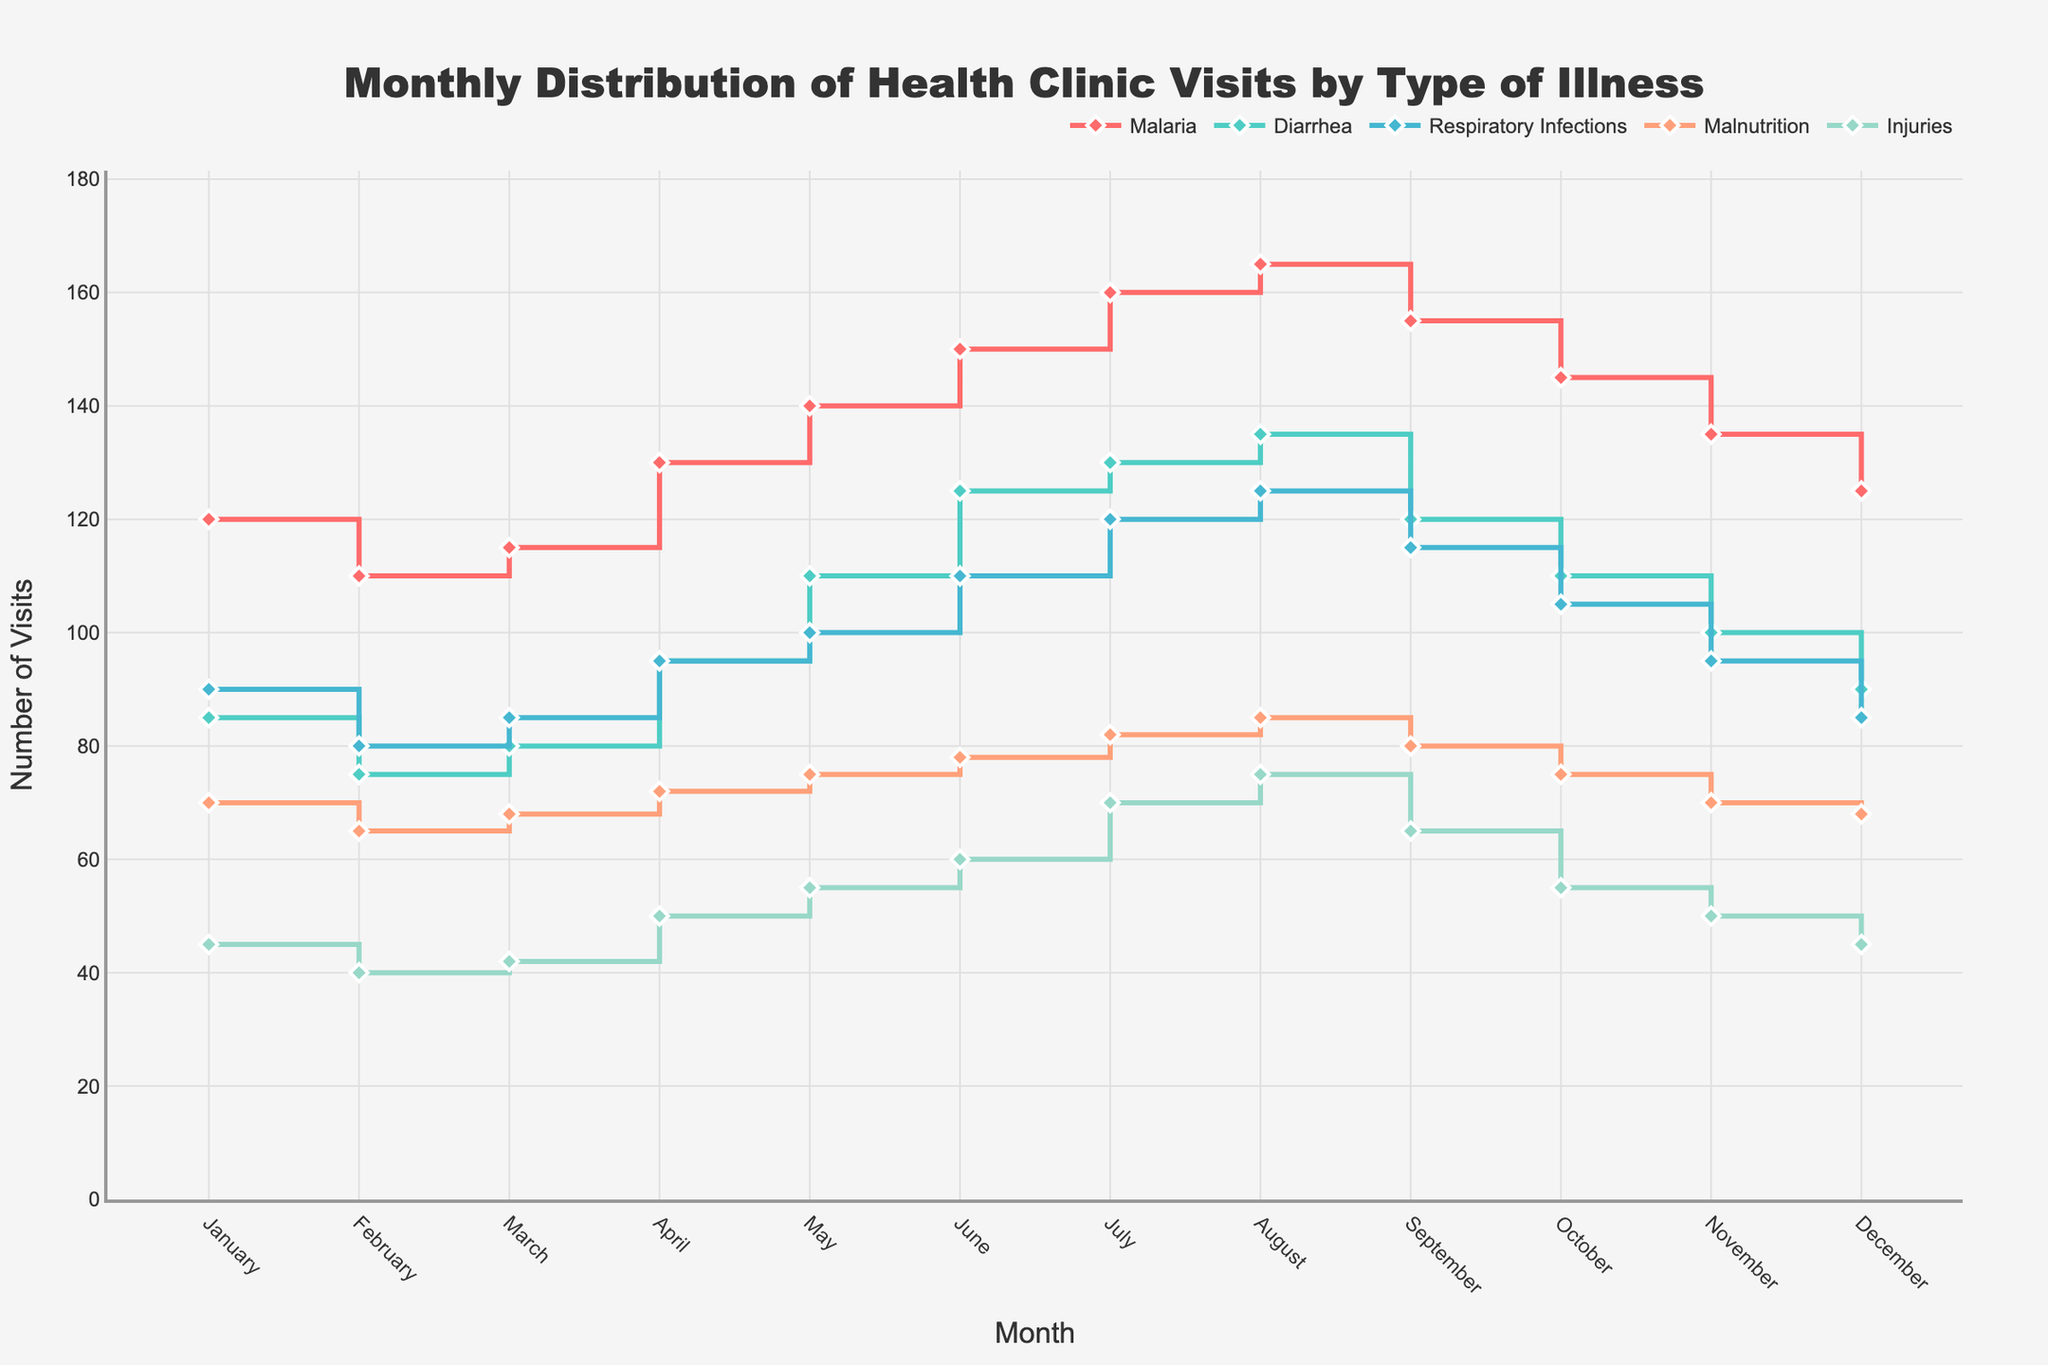What is the title of the plot? The title of the plot is usually the main heading at the top, which helps describe the data being shown. The title here specifically mentions the subject being depicted.
Answer: Monthly Distribution of Health Clinic Visits by Type of Illness What type of illness had the highest number of visits in July? To answer this, look for all the illnesses plotted for July and identify the one with the highest value.
Answer: Malaria How many health clinic visits were recorded for Malnutrition in April? Find the plot line for Malnutrition and look at the value where April is located.
Answer: 72 Which month had the highest number of visits for Injuries? Look at the values for Injuries across all months and identify the month with the highest value.
Answer: August What is the difference between the highest and lowest number of visits for Malaria? First, find the highest and lowest values for Malaria recorded in any month. Then, subtract the lowest value from the highest value. Highest (August: 165), Lowest (February: 110), Difference: 165 - 110.
Answer: 55 What is the average number of clinic visits for Diarrhea in the first quarter of the year (Jan-Mar)? Add up the number of visits for Diarrhea in January, February, and March and divide by the number of months (3). (85 + 75 + 80) / 3 = 80
Answer: 80 How does the number of visits for Respiratory Infections in December compare to November? Compare the values for Respiratory Infections in December and November. December: 85, November: 95.
Answer: December is 10 less than November Which illness shows the most consistent number of visits throughout the year? Look at the plot lines for all illnesses and observe which one has the least fluctuation or variation in values across months.
Answer: Malnutrition Identify the month where Malaria visits start a continuous increase until peaking. Observe the trend of Malaria across months and identify the month where a continuous upward trend begins until it reaches its highest value. The increase starts in April and peaks in August.
Answer: April What is the combined number of visits for Diarrhea and Injuries in October? Add the values for Diarrhea and Injuries in October. Diarrhea: 110, Injuries: 55, Sum = 110 + 55 = 165.
Answer: 165 